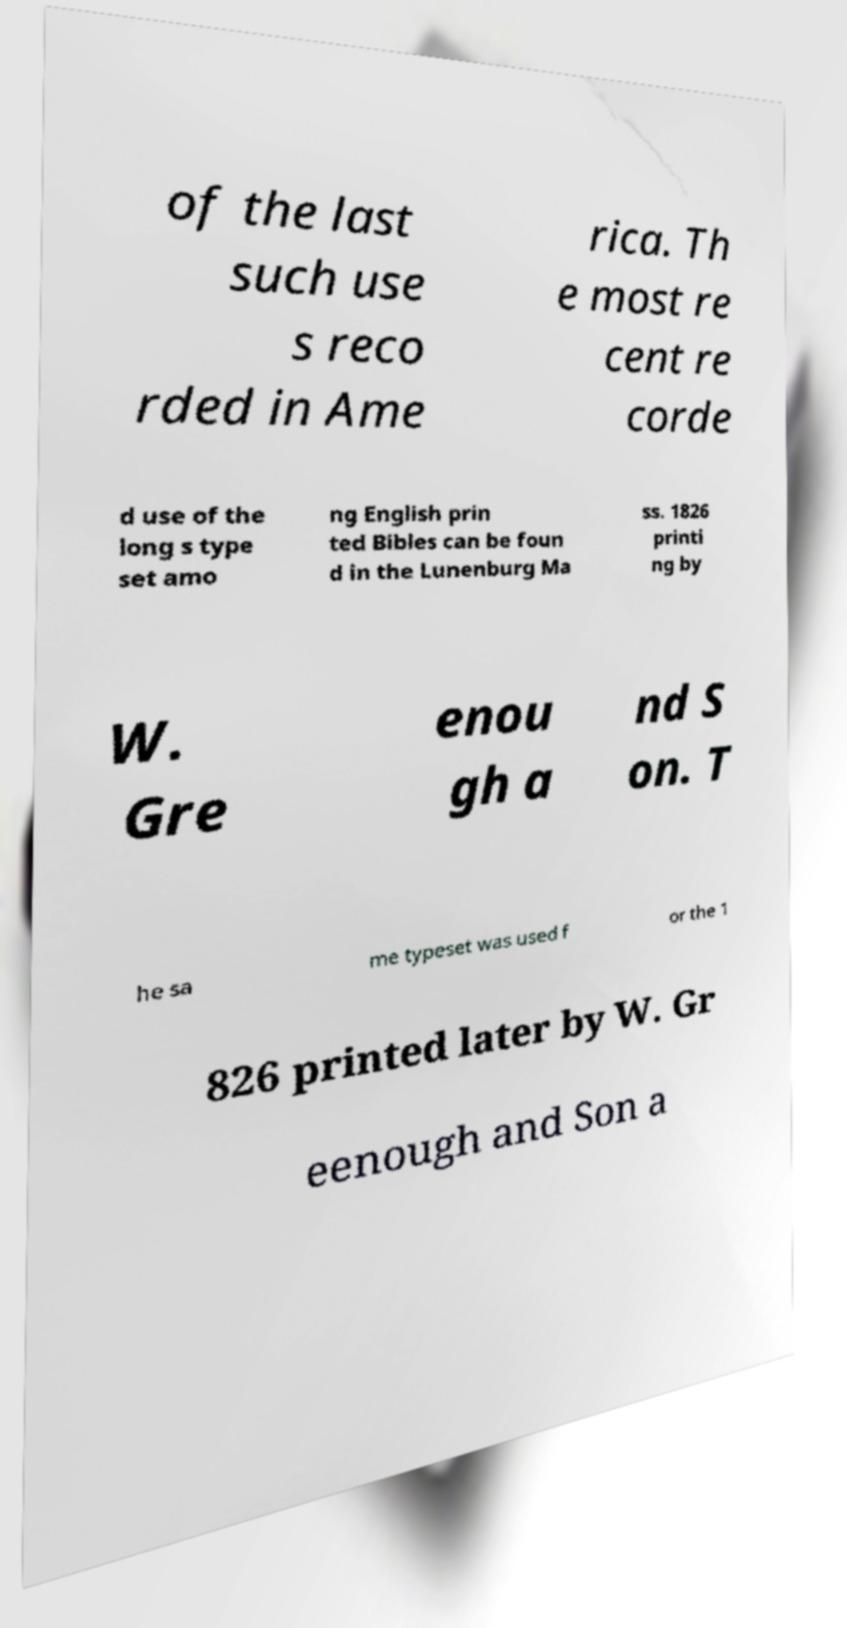Can you accurately transcribe the text from the provided image for me? of the last such use s reco rded in Ame rica. Th e most re cent re corde d use of the long s type set amo ng English prin ted Bibles can be foun d in the Lunenburg Ma ss. 1826 printi ng by W. Gre enou gh a nd S on. T he sa me typeset was used f or the 1 826 printed later by W. Gr eenough and Son a 